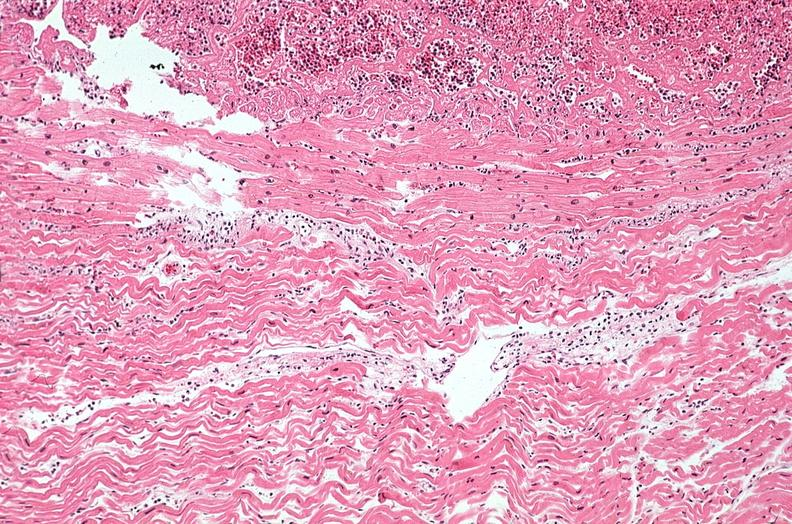s cardiovascular present?
Answer the question using a single word or phrase. Yes 